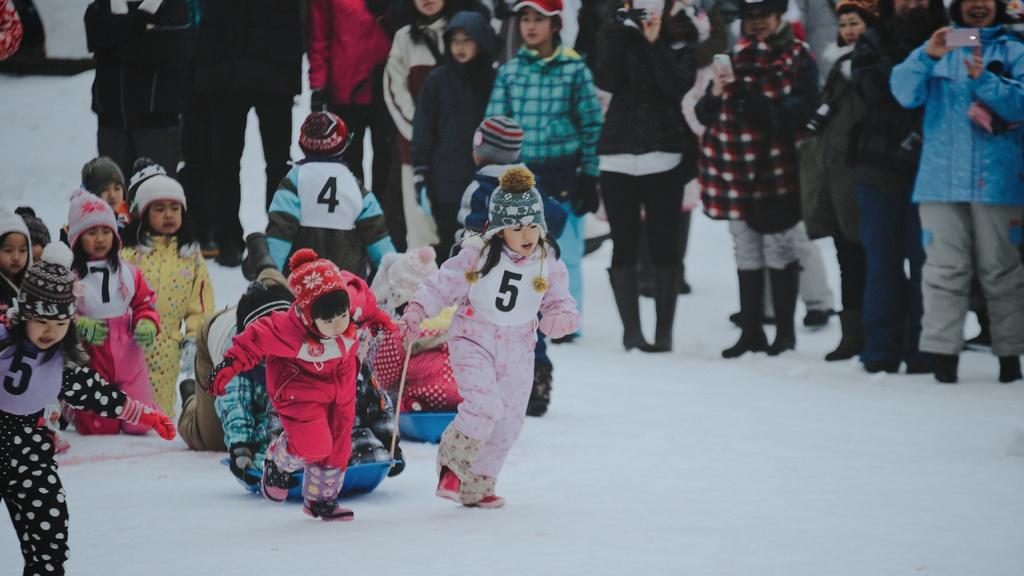What are the children doing in the image? The children are running on the snow. What are the children holding while running? The children are holding ropes and blue trays. What are the other children doing in the image? Other children are sitting on the blue trays. Are there any spectators in the image? Yes, people are standing and watching the children. What type of bomb can be seen in the image? There is no bomb present in the image. Can you tell me how many animals are visible in the zoo in the image? There is no zoo present in the image. 